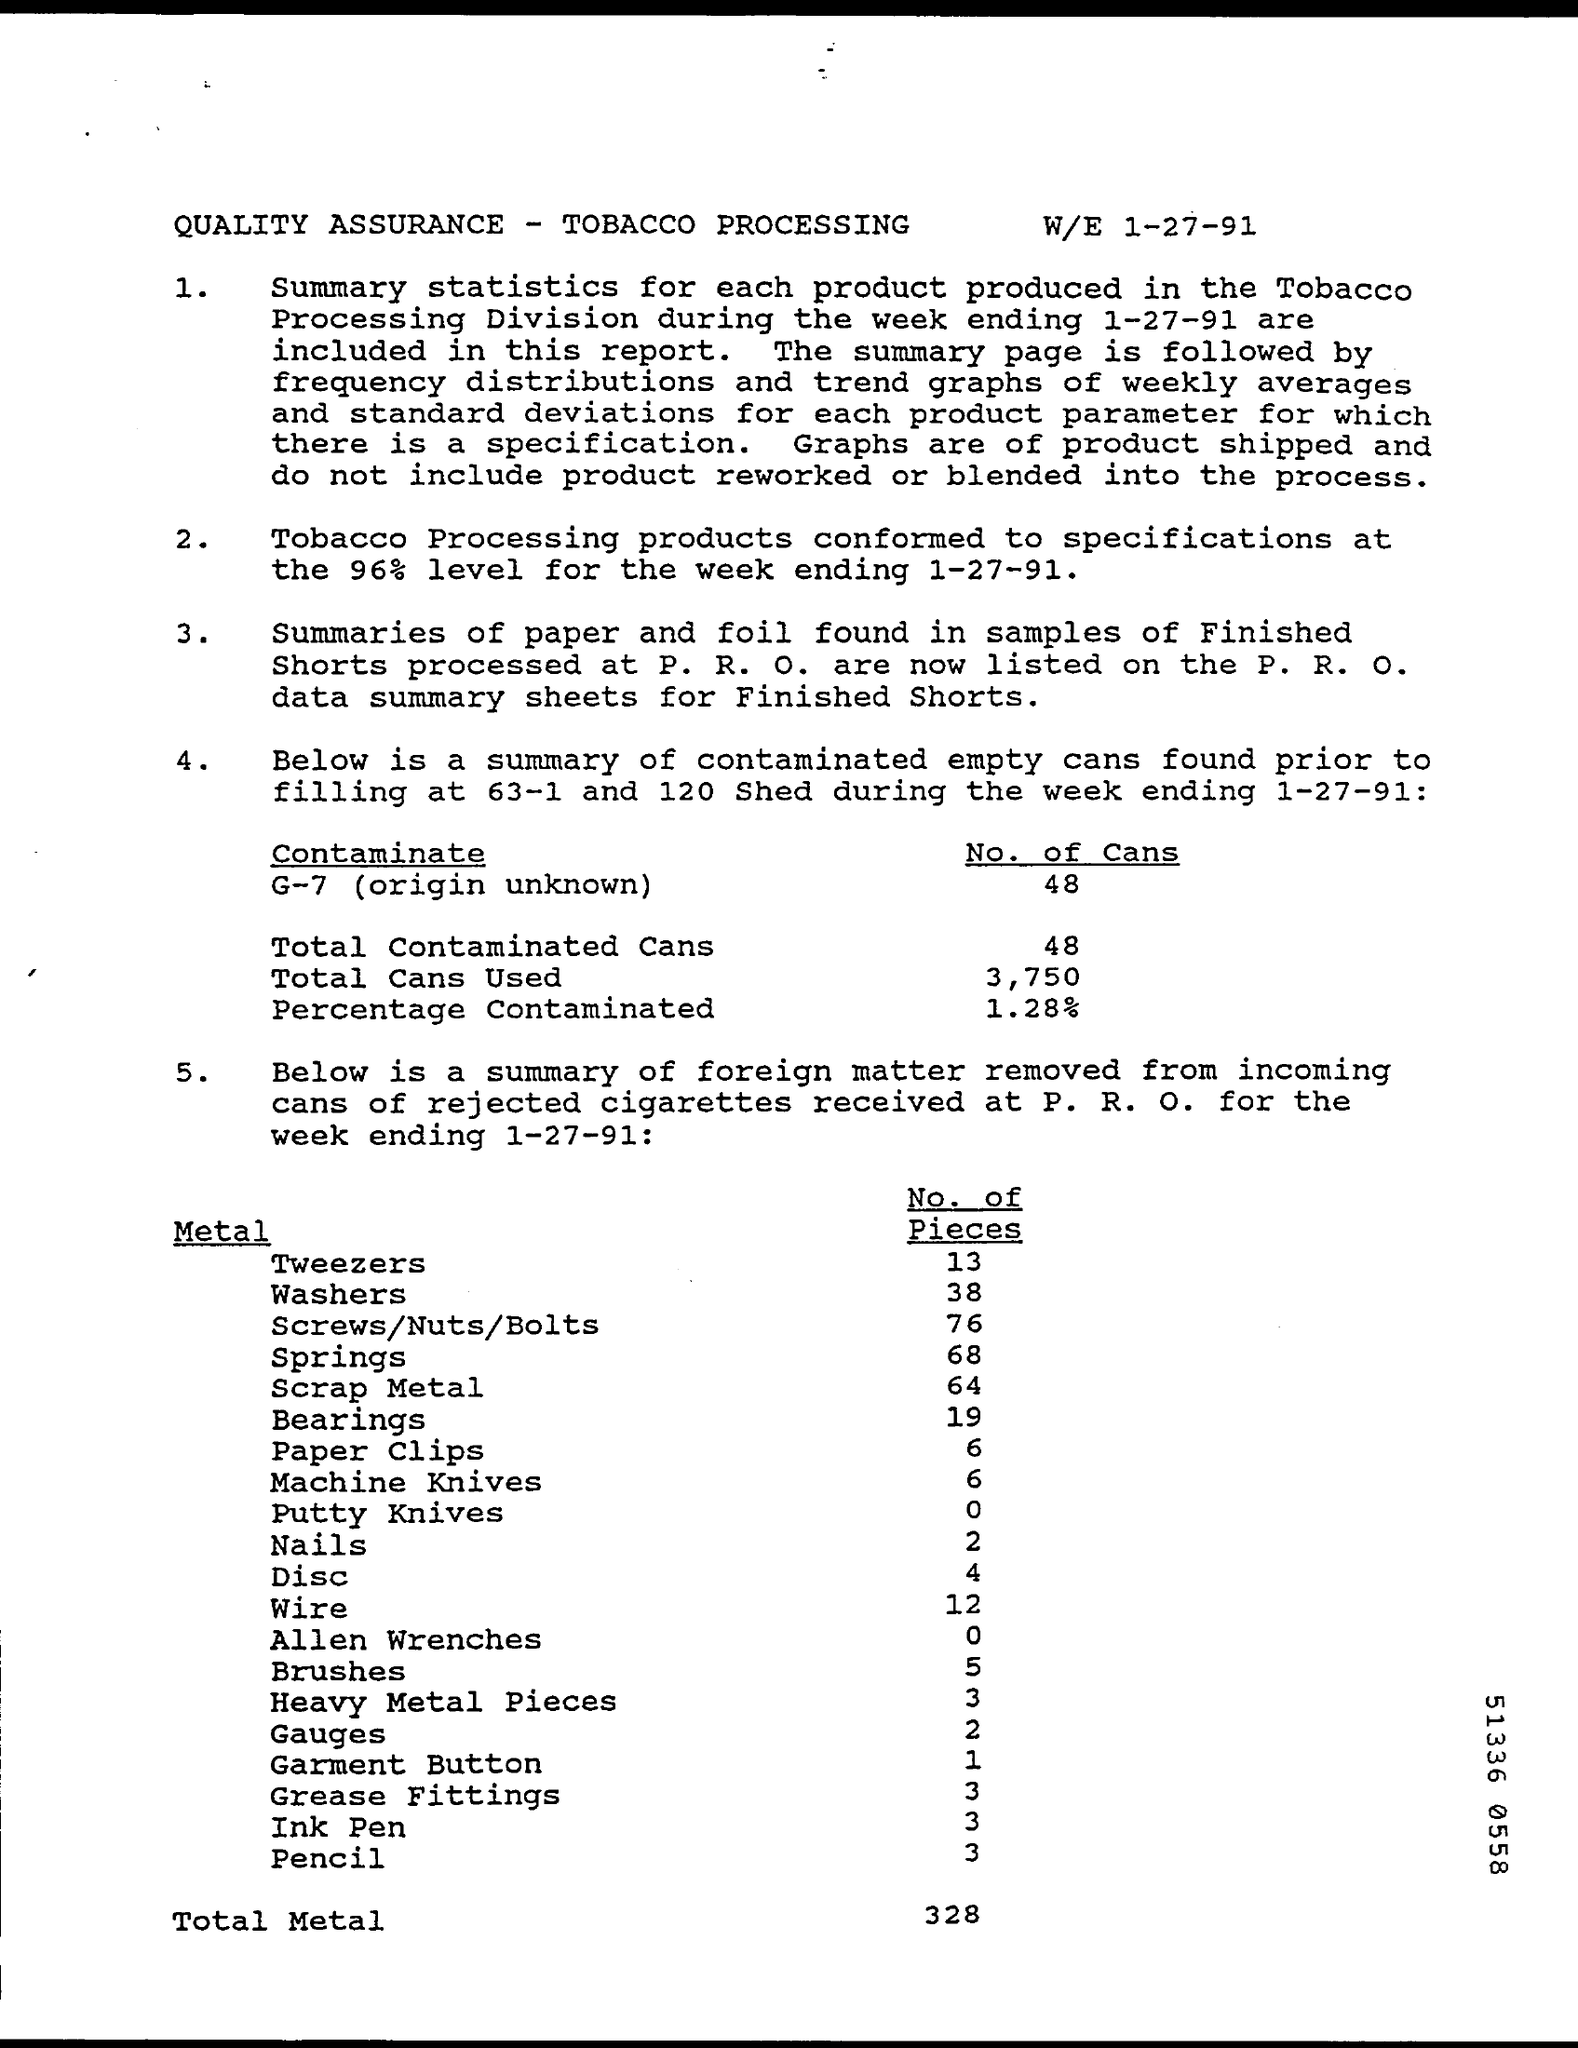What is the Title of the document?
Give a very brief answer. QUALITY ASSURANCE - TOBACCO PROCESSING. What are the No. of Cans with Contaminate G-7 ?
Your answer should be compact. 48. What is the Total contaminated Cans?
Your answer should be very brief. 48. What are the Total Cans Used?
Provide a short and direct response. 3,750. What is the Percentage Contaminated?
Make the answer very short. 1.28%. What is the No. of Pieces of "Tweezers"?
Make the answer very short. 13. What is the No. of Pieces of "Washers"?
Keep it short and to the point. 38. What is the No. of Pieces of "Springs"?
Your answer should be very brief. 68. What is the No. of Pieces of "Nails"?
Offer a very short reply. 2. What is the No. of Pieces of "Wire"?
Make the answer very short. 12. 